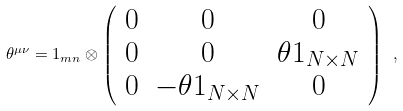<formula> <loc_0><loc_0><loc_500><loc_500>\theta ^ { \mu \nu } = 1 _ { m n } \otimes \left ( \begin{array} { c c c } 0 & 0 & 0 \\ 0 & 0 & \theta 1 _ { N \times N } \\ 0 & - \theta 1 _ { N \times N } & 0 \\ \end{array} \right ) \ ,</formula> 